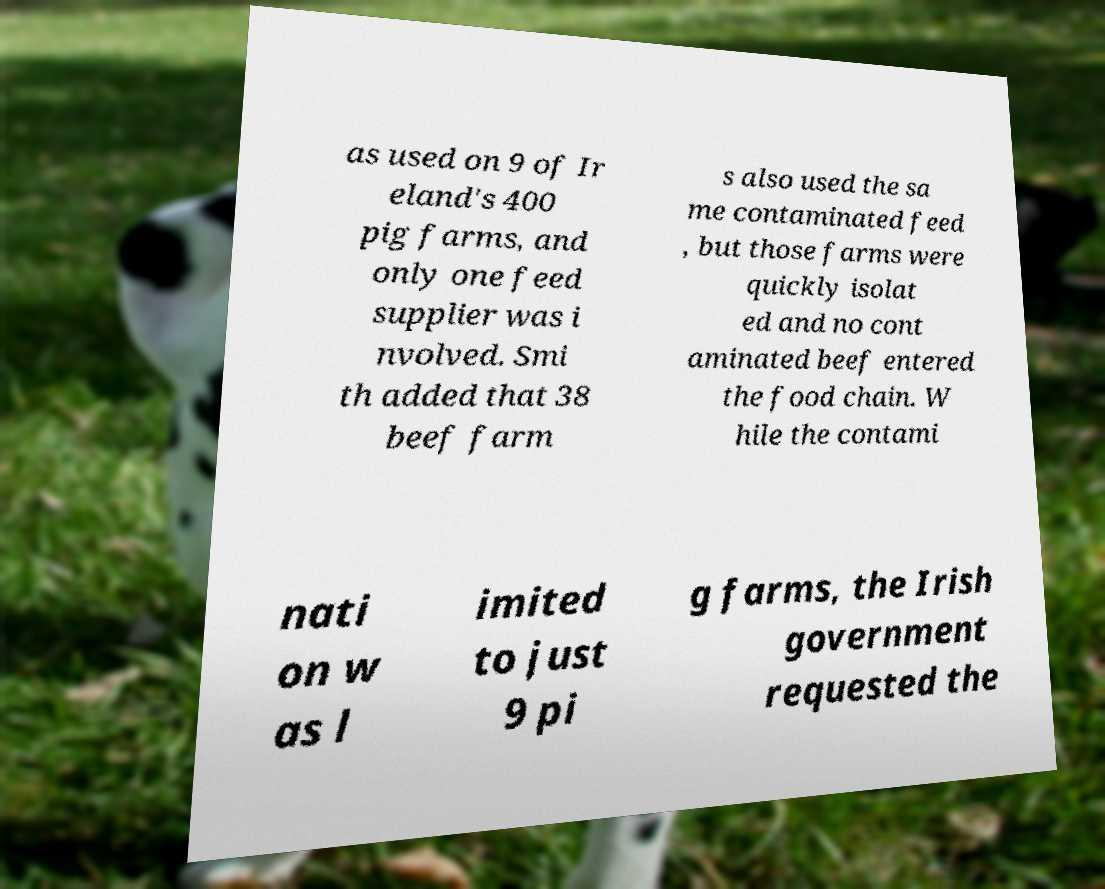Can you accurately transcribe the text from the provided image for me? as used on 9 of Ir eland's 400 pig farms, and only one feed supplier was i nvolved. Smi th added that 38 beef farm s also used the sa me contaminated feed , but those farms were quickly isolat ed and no cont aminated beef entered the food chain. W hile the contami nati on w as l imited to just 9 pi g farms, the Irish government requested the 